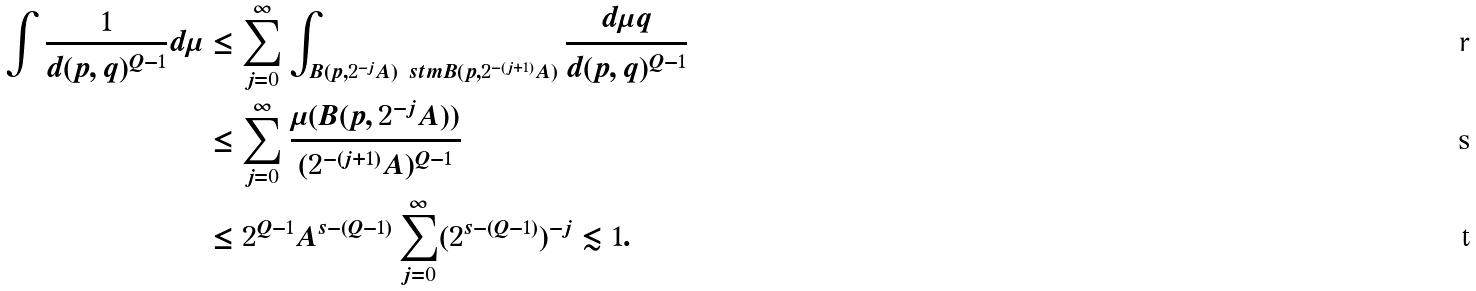Convert formula to latex. <formula><loc_0><loc_0><loc_500><loc_500>\int \frac { 1 } { d ( p , q ) ^ { Q - 1 } } d \mu & \leq \sum _ { j = 0 } ^ { \infty } \int _ { B ( p , 2 ^ { - j } A ) \ s t m B ( p , 2 ^ { - ( j + 1 ) } A ) } \frac { d \mu q } { d ( p , q ) ^ { Q - 1 } } \\ & \leq \sum _ { j = 0 } ^ { \infty } \frac { \mu ( B ( p , 2 ^ { - j } A ) ) } { ( 2 ^ { - ( j + 1 ) } A ) ^ { Q - 1 } } \\ & \leq 2 ^ { Q - 1 } A ^ { s - ( Q - 1 ) } \sum _ { j = 0 } ^ { \infty } ( 2 ^ { s - ( Q - 1 ) } ) ^ { - j } \lesssim 1 .</formula> 